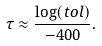<formula> <loc_0><loc_0><loc_500><loc_500>\tau \approx \frac { \log ( t o l ) } { - 4 0 0 } .</formula> 